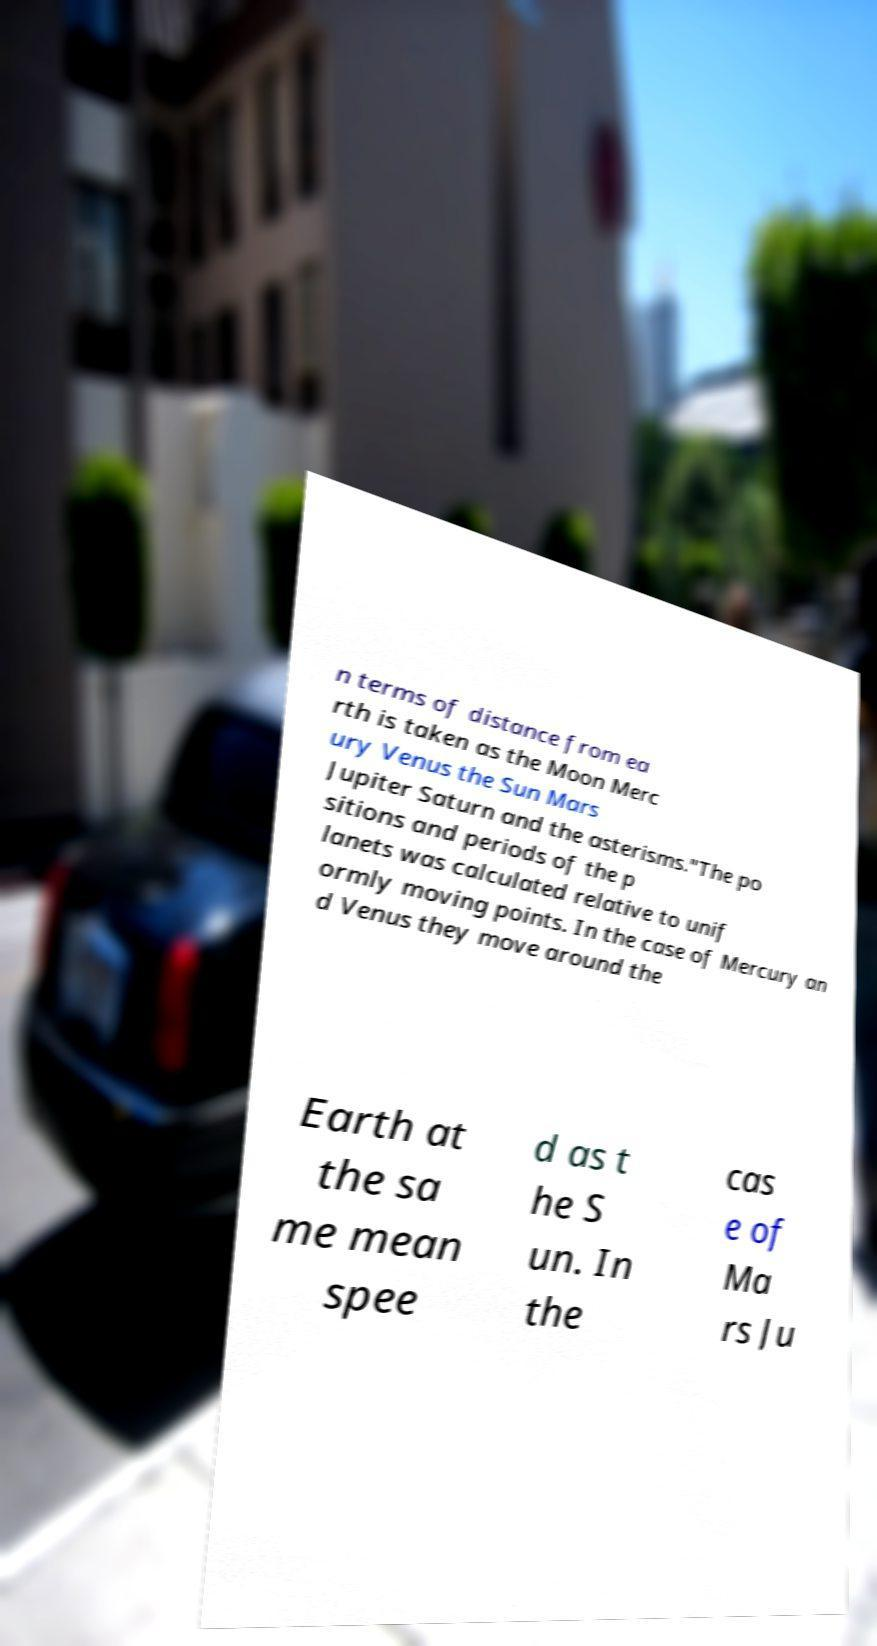For documentation purposes, I need the text within this image transcribed. Could you provide that? n terms of distance from ea rth is taken as the Moon Merc ury Venus the Sun Mars Jupiter Saturn and the asterisms."The po sitions and periods of the p lanets was calculated relative to unif ormly moving points. In the case of Mercury an d Venus they move around the Earth at the sa me mean spee d as t he S un. In the cas e of Ma rs Ju 